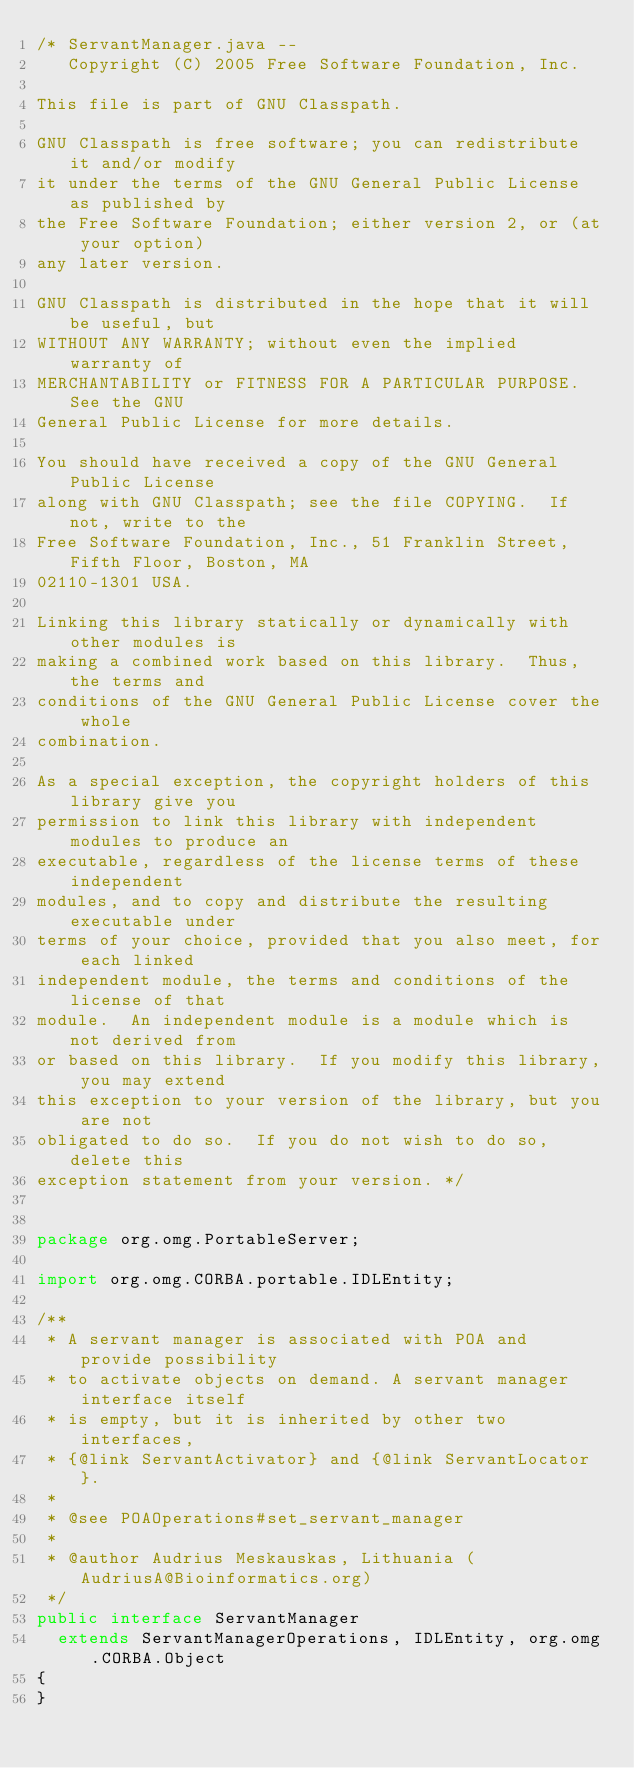Convert code to text. <code><loc_0><loc_0><loc_500><loc_500><_Java_>/* ServantManager.java --
   Copyright (C) 2005 Free Software Foundation, Inc.

This file is part of GNU Classpath.

GNU Classpath is free software; you can redistribute it and/or modify
it under the terms of the GNU General Public License as published by
the Free Software Foundation; either version 2, or (at your option)
any later version.

GNU Classpath is distributed in the hope that it will be useful, but
WITHOUT ANY WARRANTY; without even the implied warranty of
MERCHANTABILITY or FITNESS FOR A PARTICULAR PURPOSE.  See the GNU
General Public License for more details.

You should have received a copy of the GNU General Public License
along with GNU Classpath; see the file COPYING.  If not, write to the
Free Software Foundation, Inc., 51 Franklin Street, Fifth Floor, Boston, MA
02110-1301 USA.

Linking this library statically or dynamically with other modules is
making a combined work based on this library.  Thus, the terms and
conditions of the GNU General Public License cover the whole
combination.

As a special exception, the copyright holders of this library give you
permission to link this library with independent modules to produce an
executable, regardless of the license terms of these independent
modules, and to copy and distribute the resulting executable under
terms of your choice, provided that you also meet, for each linked
independent module, the terms and conditions of the license of that
module.  An independent module is a module which is not derived from
or based on this library.  If you modify this library, you may extend
this exception to your version of the library, but you are not
obligated to do so.  If you do not wish to do so, delete this
exception statement from your version. */


package org.omg.PortableServer;

import org.omg.CORBA.portable.IDLEntity;

/**
 * A servant manager is associated with POA and provide possibility
 * to activate objects on demand. A servant manager interface itself
 * is empty, but it is inherited by other two interfaces,
 * {@link ServantActivator} and {@link ServantLocator}.
 *
 * @see POAOperations#set_servant_manager
 *
 * @author Audrius Meskauskas, Lithuania (AudriusA@Bioinformatics.org)
 */
public interface ServantManager
  extends ServantManagerOperations, IDLEntity, org.omg.CORBA.Object
{
}</code> 